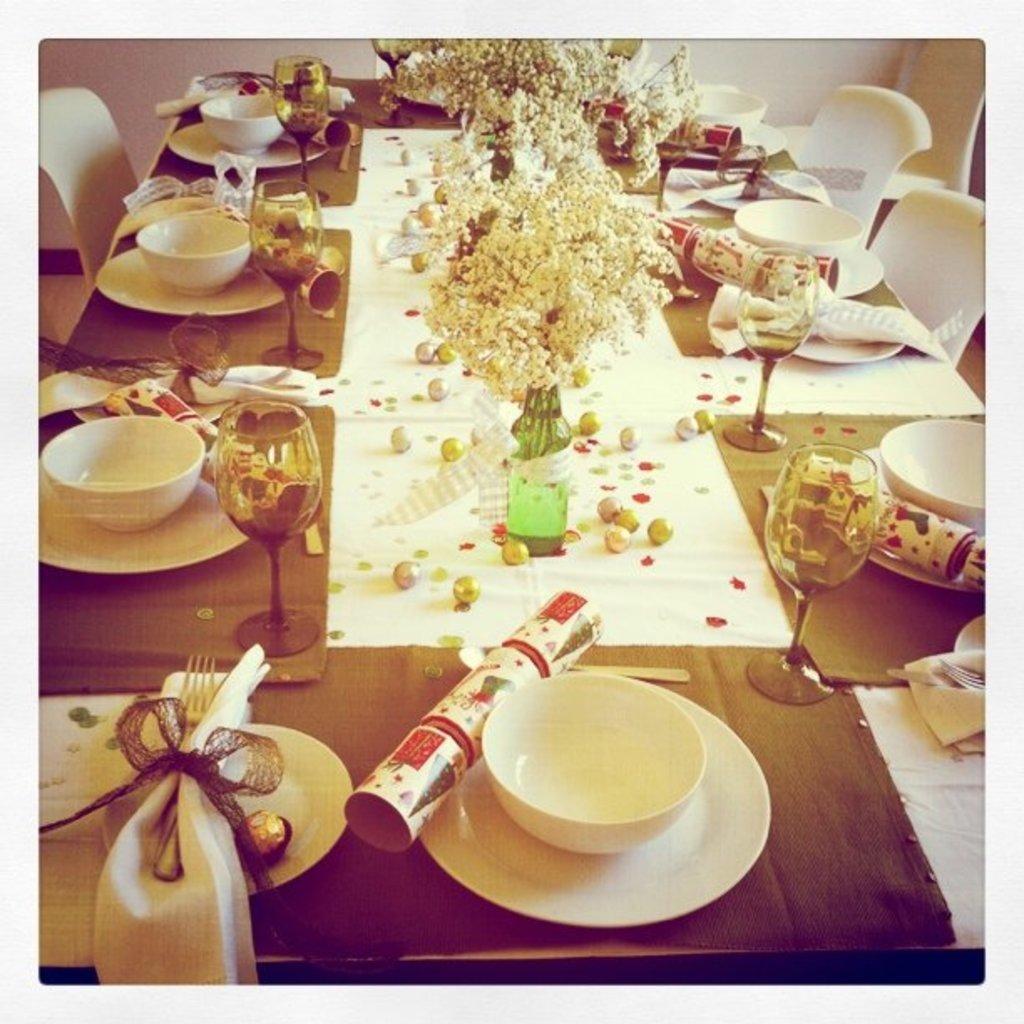Can you describe this image briefly? On this table there are flower vase with ribbon, glasses, bowls, card, plates and balls. Beside this table there are chairs in white color. 